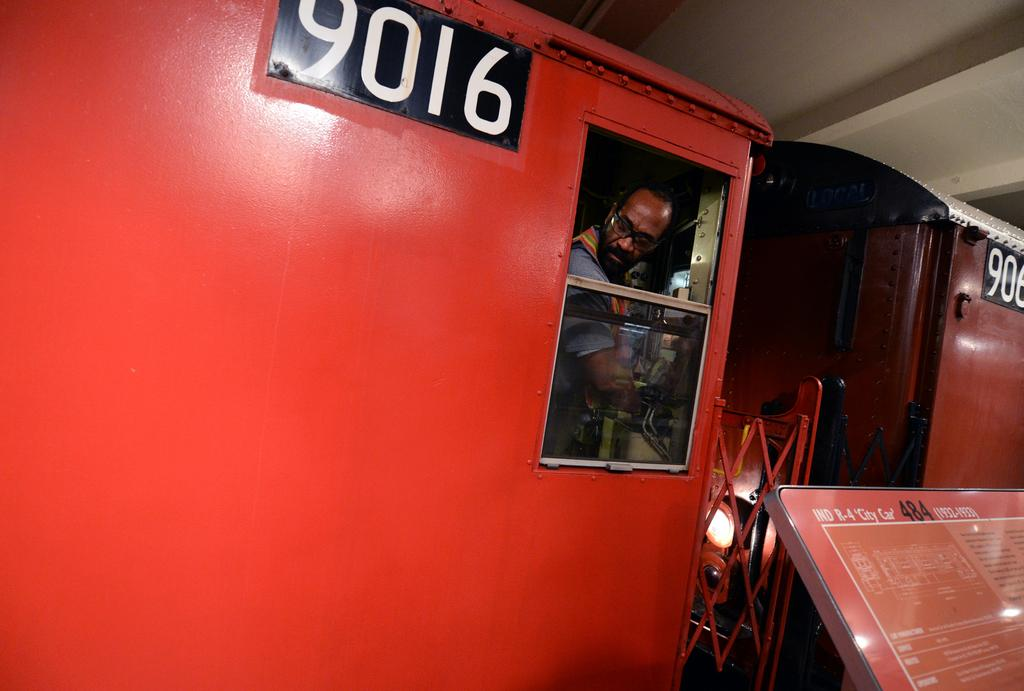What is the main subject of the image? The main subject of the image is a train. Can you describe any other elements in the image? Yes, there is a person and a board with text on the right side of the image. What type of throne can be seen in the image? There is no throne present in the image. Is the train in motion in the image? The image does not provide information about the train's motion, so it cannot be determined from the image. 